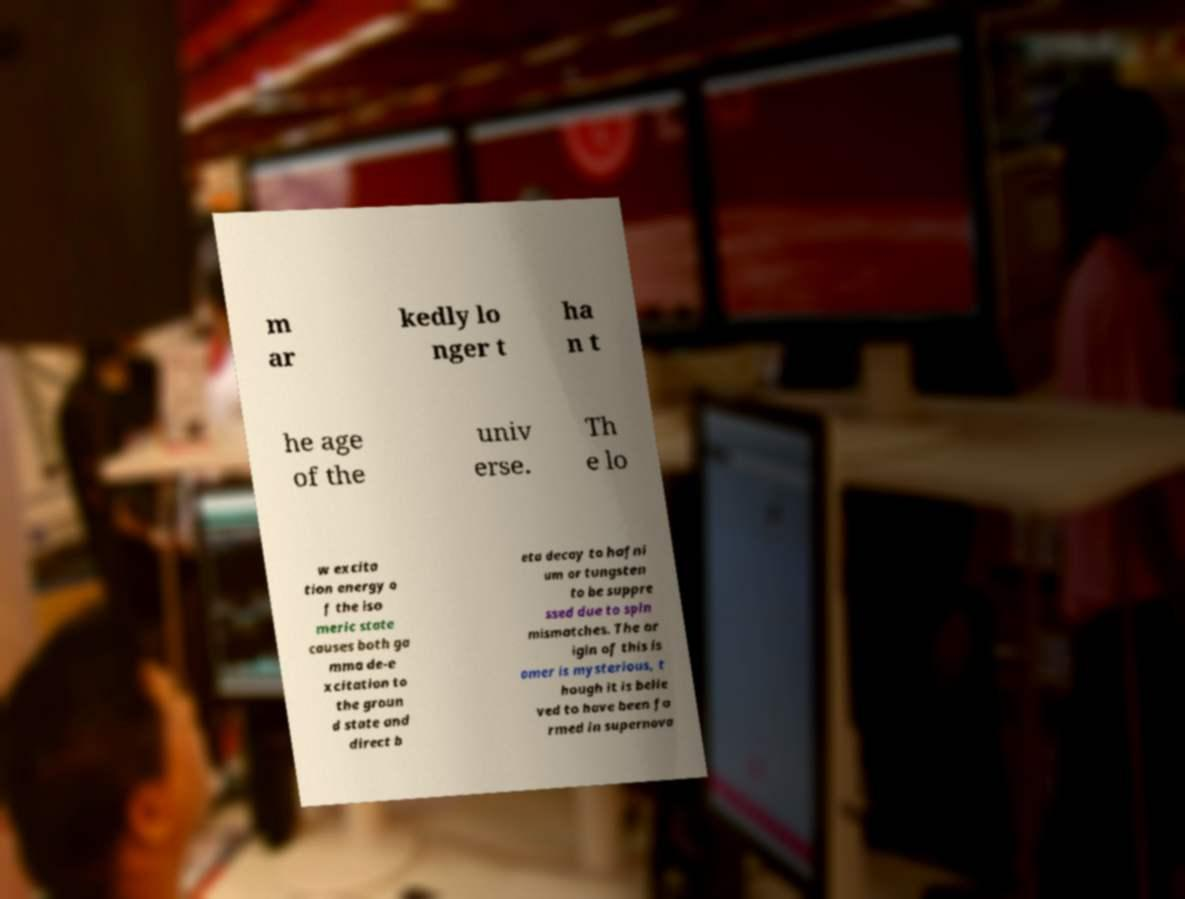Could you assist in decoding the text presented in this image and type it out clearly? m ar kedly lo nger t ha n t he age of the univ erse. Th e lo w excita tion energy o f the iso meric state causes both ga mma de-e xcitation to the groun d state and direct b eta decay to hafni um or tungsten to be suppre ssed due to spin mismatches. The or igin of this is omer is mysterious, t hough it is belie ved to have been fo rmed in supernova 